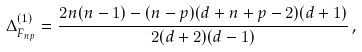Convert formula to latex. <formula><loc_0><loc_0><loc_500><loc_500>\Delta ^ { ( 1 ) } _ { F _ { n p } } = \frac { 2 n ( n - 1 ) - ( n - p ) ( d + n + p - 2 ) ( d + 1 ) } { 2 ( d + 2 ) ( d - 1 ) } \, ,</formula> 